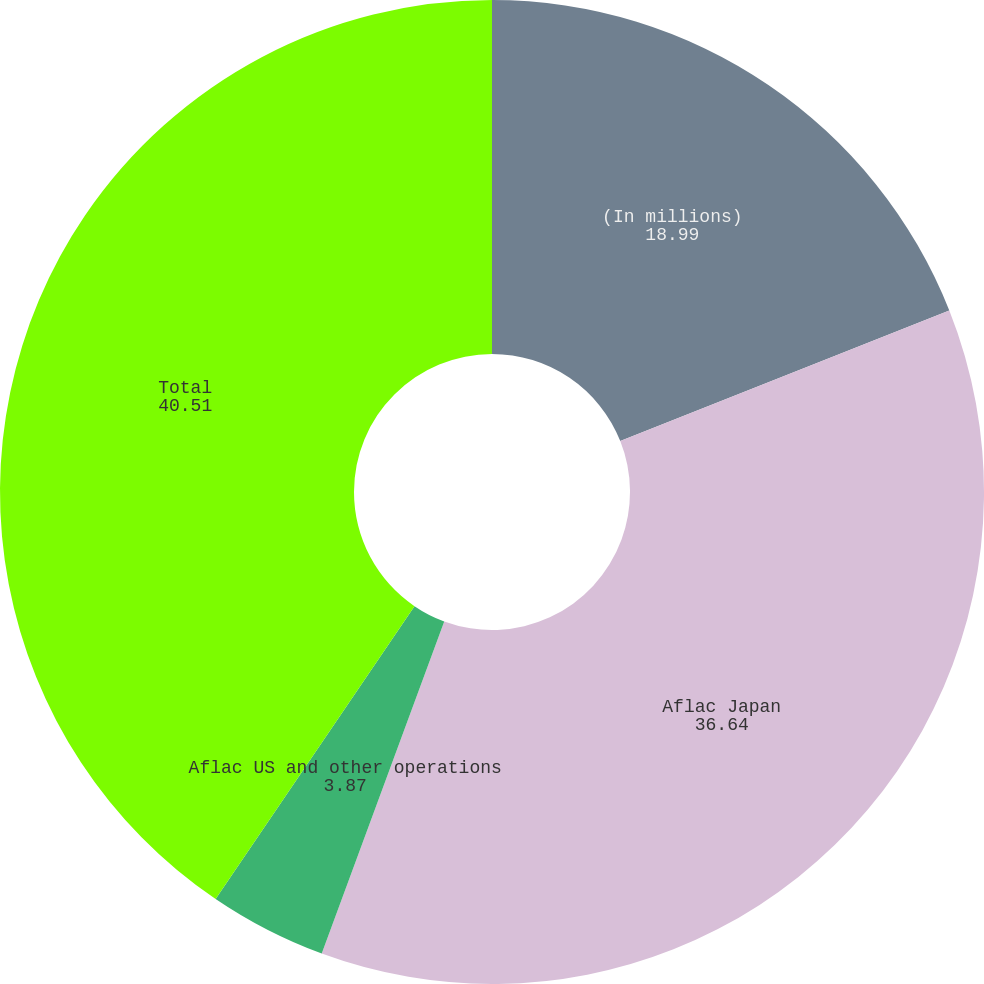<chart> <loc_0><loc_0><loc_500><loc_500><pie_chart><fcel>(In millions)<fcel>Aflac Japan<fcel>Aflac US and other operations<fcel>Total<nl><fcel>18.99%<fcel>36.64%<fcel>3.87%<fcel>40.51%<nl></chart> 